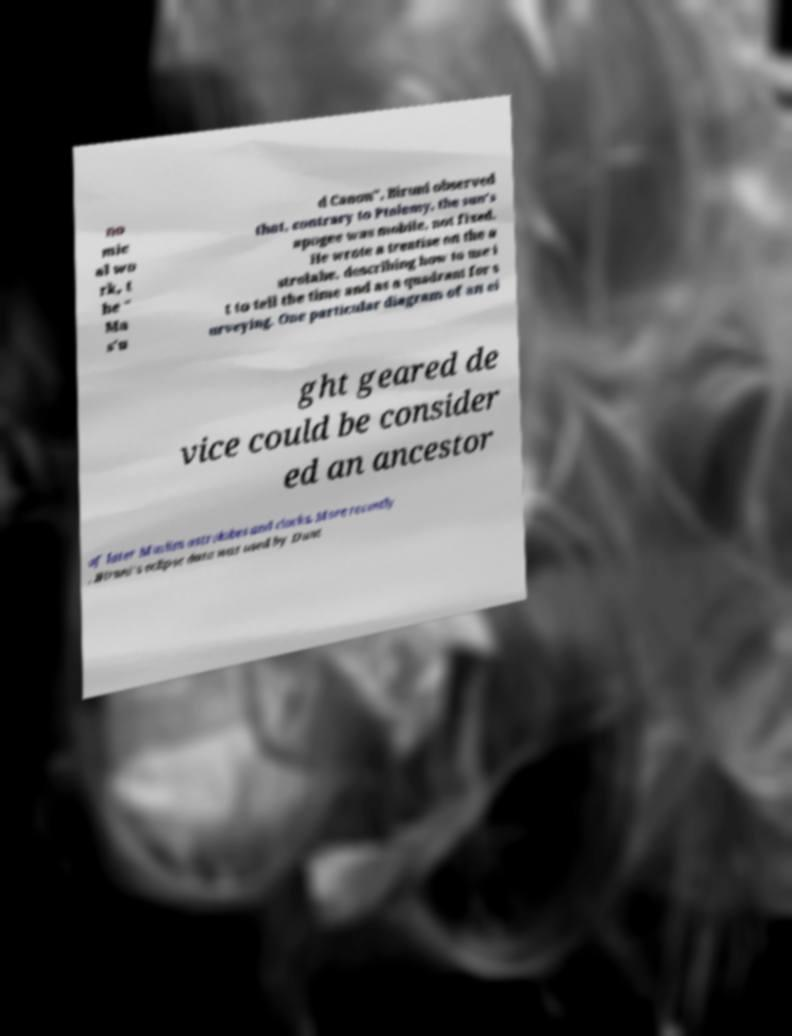What messages or text are displayed in this image? I need them in a readable, typed format. no mic al wo rk, t he " Ma s'u d Canon", Biruni observed that, contrary to Ptolemy, the sun's apogee was mobile, not fixed. He wrote a treatise on the a strolabe, describing how to use i t to tell the time and as a quadrant for s urveying. One particular diagram of an ei ght geared de vice could be consider ed an ancestor of later Muslim astrolabes and clocks. More recently , Biruni's eclipse data was used by Dunt 